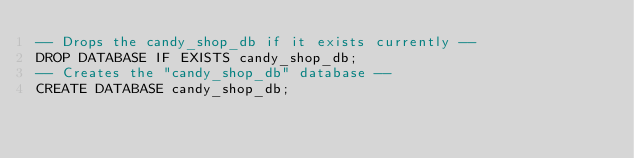<code> <loc_0><loc_0><loc_500><loc_500><_SQL_>-- Drops the candy_shop_db if it exists currently --
DROP DATABASE IF EXISTS candy_shop_db;
-- Creates the "candy_shop_db" database --
CREATE DATABASE candy_shop_db;
</code> 